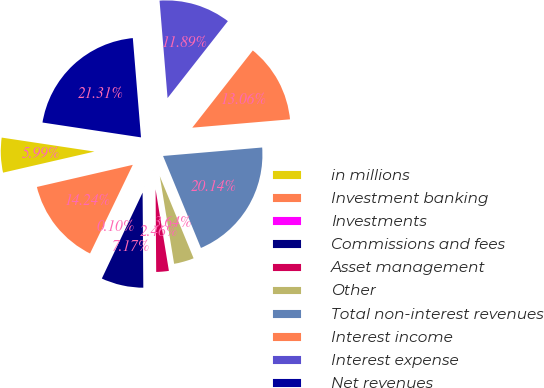<chart> <loc_0><loc_0><loc_500><loc_500><pie_chart><fcel>in millions<fcel>Investment banking<fcel>Investments<fcel>Commissions and fees<fcel>Asset management<fcel>Other<fcel>Total non-interest revenues<fcel>Interest income<fcel>Interest expense<fcel>Net revenues<nl><fcel>5.99%<fcel>14.24%<fcel>0.1%<fcel>7.17%<fcel>2.46%<fcel>3.64%<fcel>20.14%<fcel>13.06%<fcel>11.89%<fcel>21.31%<nl></chart> 